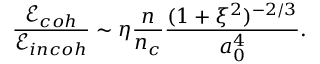Convert formula to latex. <formula><loc_0><loc_0><loc_500><loc_500>\frac { \mathcal { E } _ { c o h } } { \mathcal { E } _ { i n c o h } } \sim \eta \frac { n } { n _ { c } } \frac { ( 1 + \xi ^ { 2 } ) ^ { - 2 / 3 } } { a _ { 0 } ^ { 4 } } .</formula> 